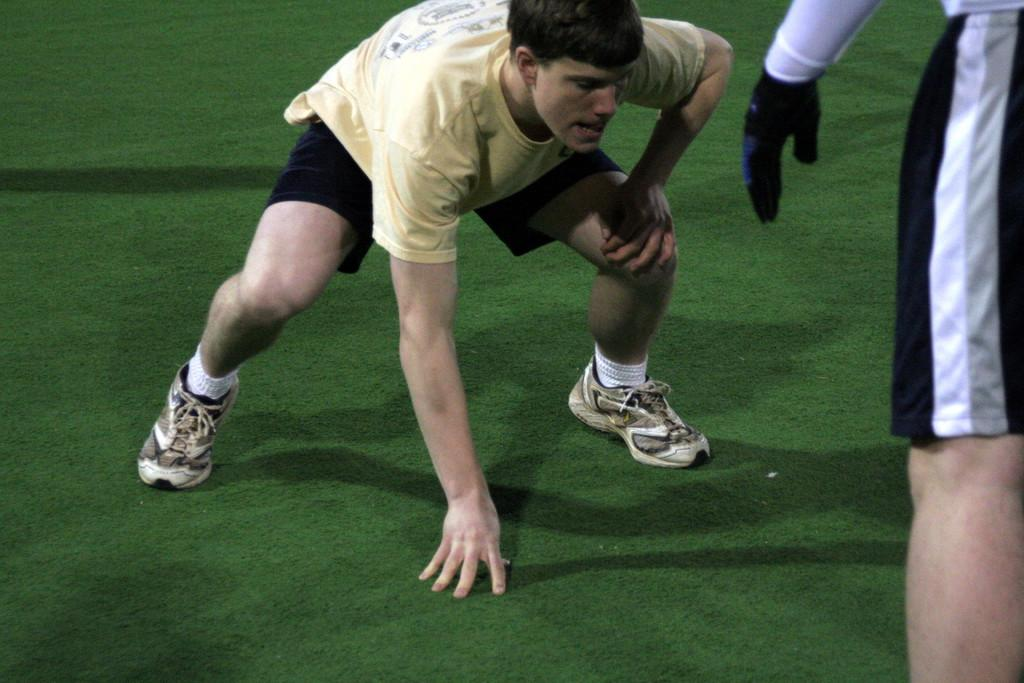Who is the main subject in the image? There is a person in the center of the image. Are there any other people visible in the image? Yes, there is another person standing on the right side of the image. What type of surface is visible in the image? There is a grass court in the image. Reasoning: Let' Let's think step by step in order to produce the conversation. We start by identifying the main subject in the image, which is the person in the center. Then, we expand the conversation to include the other person visible in the image. Finally, we describe the setting or environment in which the people are located, which is a grass court. Each question is designed to elicit a specific detail about the image that is known from the provided facts. Absurd Question/Answer: What type of cheese is being served by the goldfish in the image? There is no cheese or goldfish present in the image. 